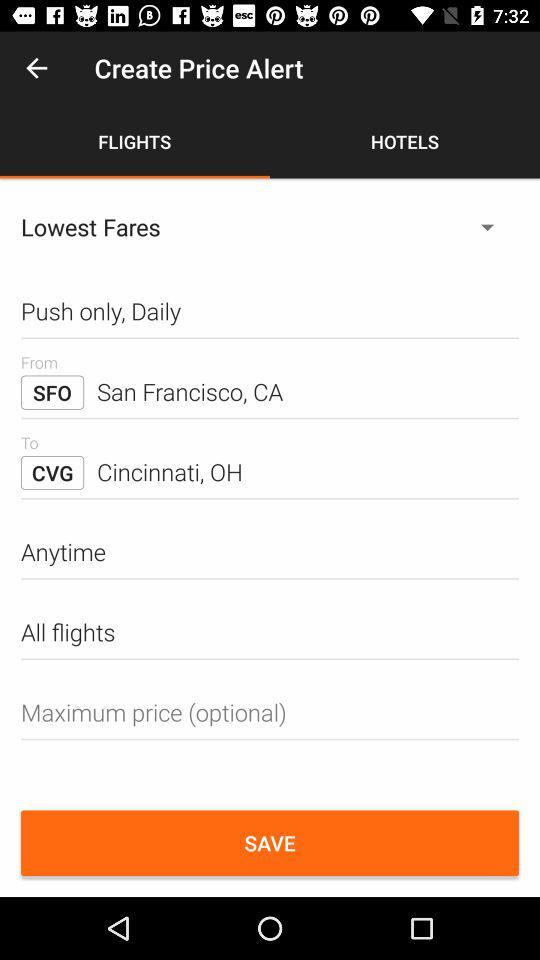What tab has been selected? The selected tab is "FLIGHTS". 